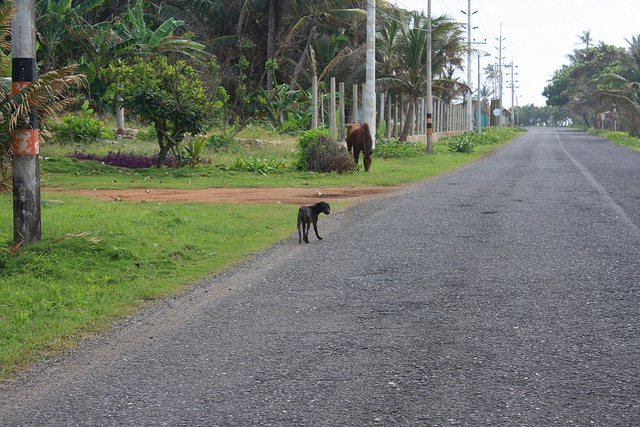Describe the objects in this image and their specific colors. I can see horse in black and gray tones and dog in black and gray tones in this image. 